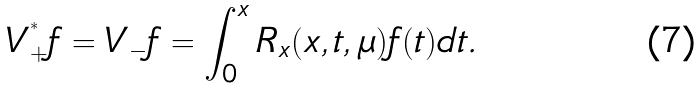Convert formula to latex. <formula><loc_0><loc_0><loc_500><loc_500>V _ { + } ^ { ^ { * } } f = V _ { - } f = \int _ { 0 } ^ { x } R _ { x } ( x , t , \mu ) f ( t ) d t .</formula> 